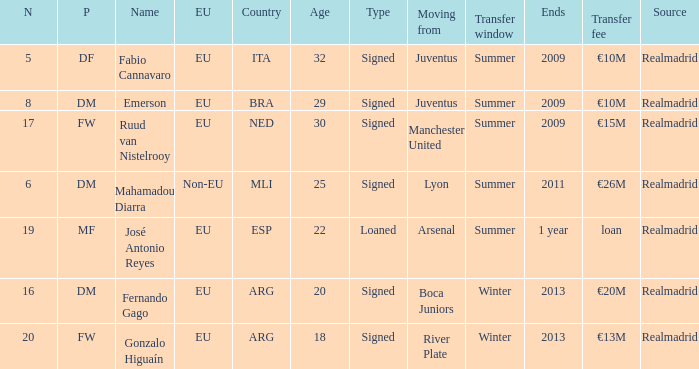How is esp classified in the european union? EU. 